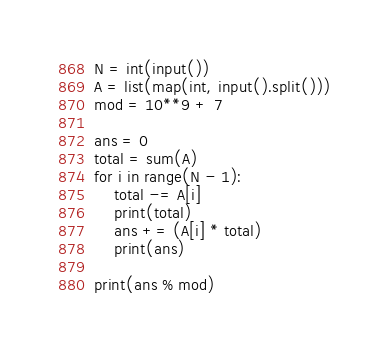<code> <loc_0><loc_0><loc_500><loc_500><_Python_>N = int(input())
A = list(map(int, input().split()))
mod = 10**9 + 7
 
ans = 0
total = sum(A)
for i in range(N - 1):
    total -= A[i]
    print(total)
    ans += (A[i] * total) 
    print(ans)
 
print(ans % mod)</code> 